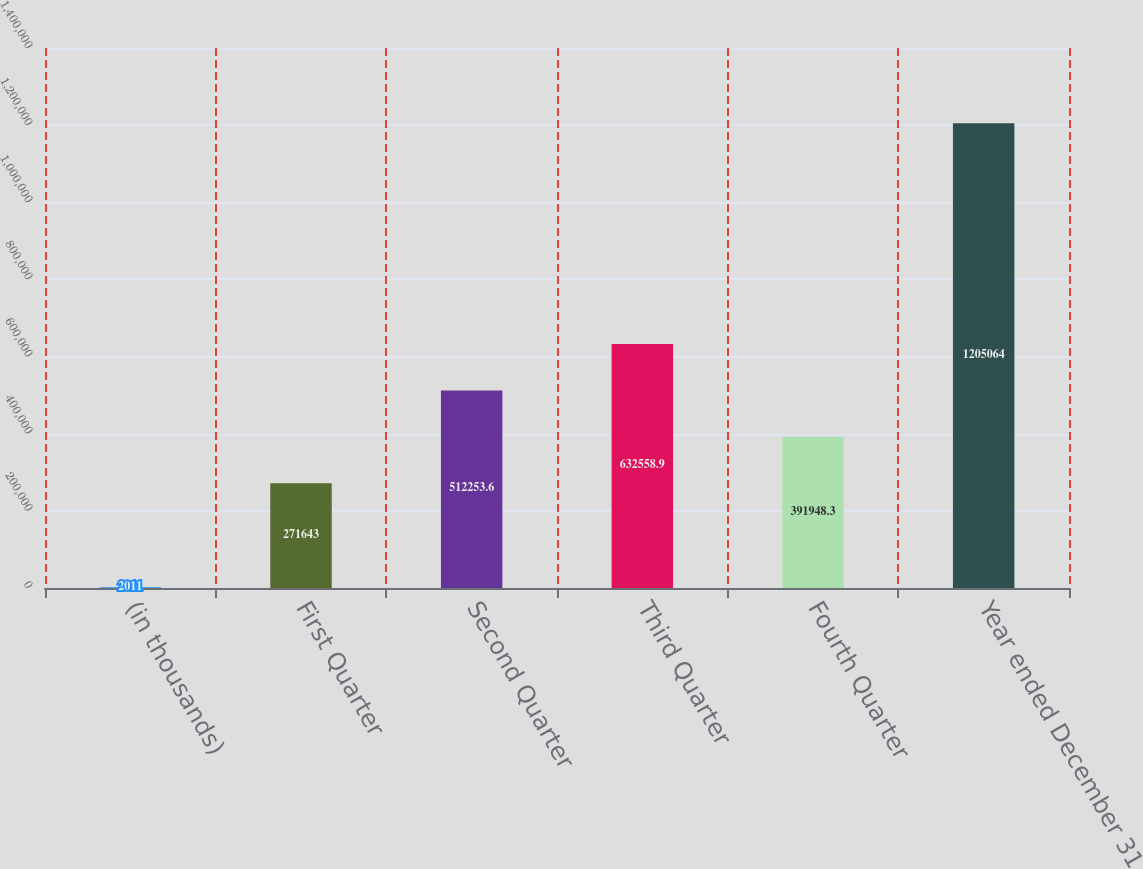Convert chart to OTSL. <chart><loc_0><loc_0><loc_500><loc_500><bar_chart><fcel>(in thousands)<fcel>First Quarter<fcel>Second Quarter<fcel>Third Quarter<fcel>Fourth Quarter<fcel>Year ended December 31<nl><fcel>2011<fcel>271643<fcel>512254<fcel>632559<fcel>391948<fcel>1.20506e+06<nl></chart> 